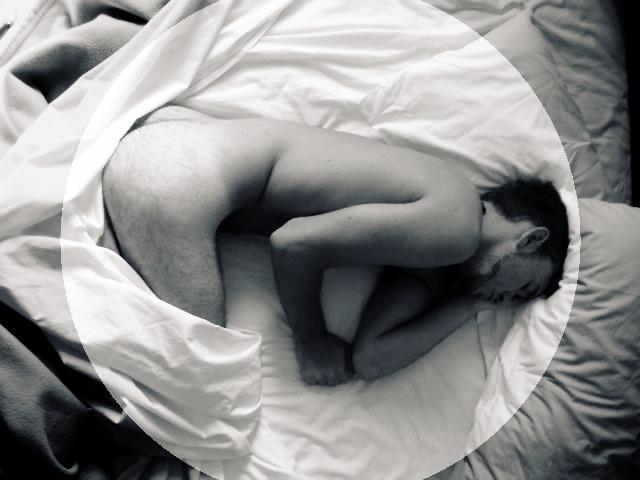Do these legs need shaving?
Short answer required. No. Is this person nude?
Short answer required. Yes. This man is sleeping on?
Be succinct. Bed. Is the person dreaming?
Give a very brief answer. Yes. Is the person holding a teddy bear?
Keep it brief. No. 